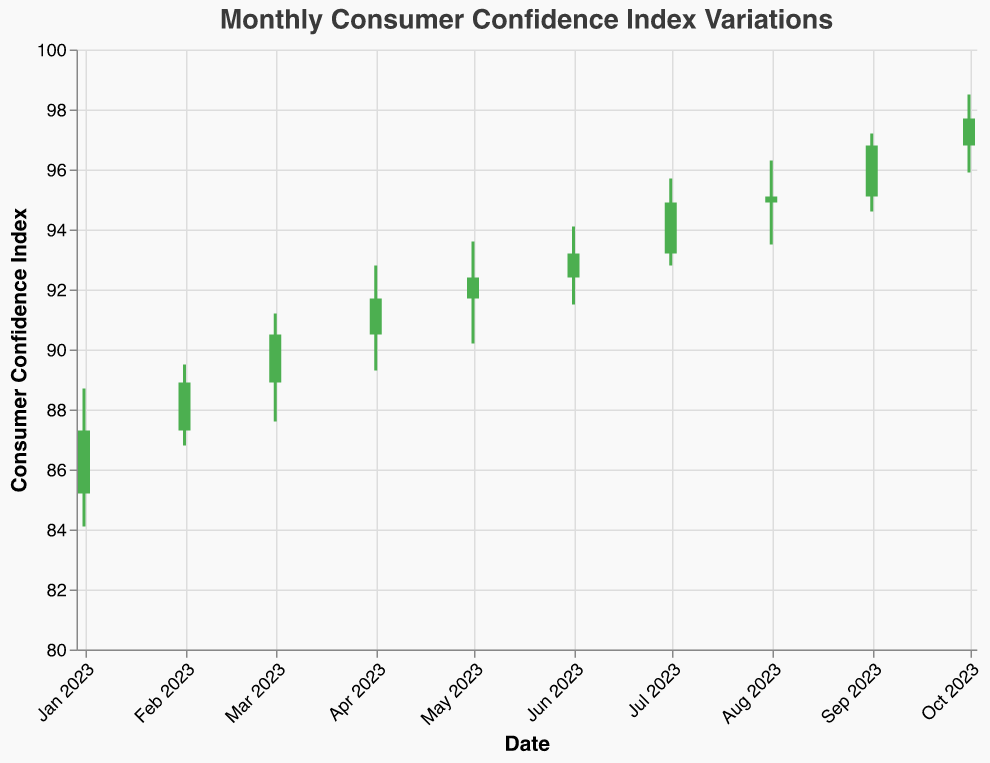What is the title of the chart? The title is usually at the top of the chart and specifies what the chart represents. Here, it's displayed as "Monthly Consumer Confidence Index Variations".
Answer: Monthly Consumer Confidence Index Variations Which month showed the highest Consumer Confidence Index at close? Look for the highest value in the "Close" column on the y-axis and find its corresponding month on the x-axis. The highest close value is for October 2023 at 97.7.
Answer: October 2023 What was the difference between the highest and lowest index values in January 2023? Identify the highest (88.7) and lowest (84.1) index values for January 2023 and subtract the lowest from the highest. 88.7 - 84.1 = 4.6
Answer: 4.6 Which marketing strategy was used in July 2023? Find the value for July 2023 on the x-axis and check the corresponding tooltip or the "Strategy" field to see the strategy used. The strategy for July 2023 is Augmented Reality Product Demonstrations.
Answer: Augmented Reality Product Demonstrations How many months had a closing index value greater than 90? Count the monthly data points where the "Close" value is greater than 90. These months are March, April, May, June, July, August, September, and October, making a total of 8 months.
Answer: 8 What is the average low index value for the months using cognitive-related marketing strategies? Identify the months with cognitive-related strategies: Neuromarketing-based Ad Design (April), Cognitive Bias-targeted Ad Placements (September), Mindfulness-based Brand Experiences (October). Extract their low values (89.3, 94.6, 95.9), then compute the average: (89.3 + 94.6 + 95.9) / 3 = 93.27.
Answer: 93.27 Which month experienced the largest volume increase from open to close? For each month, calculate the difference between the Close and Open values, and identify the highest difference. January (2.1), February (1.6), March (1.6), April (1.2), May (0.7), June (0.8), July (1.7), August (0.2), September (1.7), October (0.9). January has the largest volume increase with 2.1.
Answer: January 2023 Between March and May, which month showed the least fluctuation in the index? Find the difference between the high and low for March (91.2-87.6=3.6), April (92.8-89.3=3.5), and May (93.6-90.2=3.4). May shows the least fluctuation with a difference of 3.4.
Answer: May 2023 